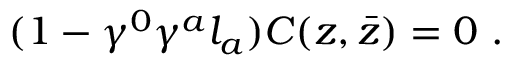<formula> <loc_0><loc_0><loc_500><loc_500>( 1 - \gamma ^ { 0 } \gamma ^ { a } l _ { a } ) C ( z , \bar { z } ) = 0 \ .</formula> 